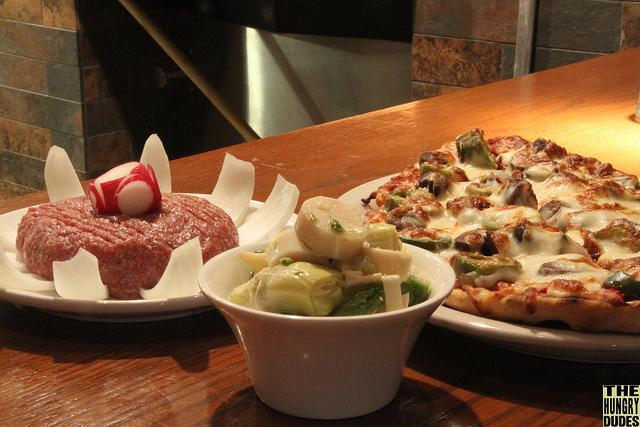What kind of meat is sat to the left of the pizza? Please explain your reasoning. ground beef. Red, ground meat is in a bowl on a table. 